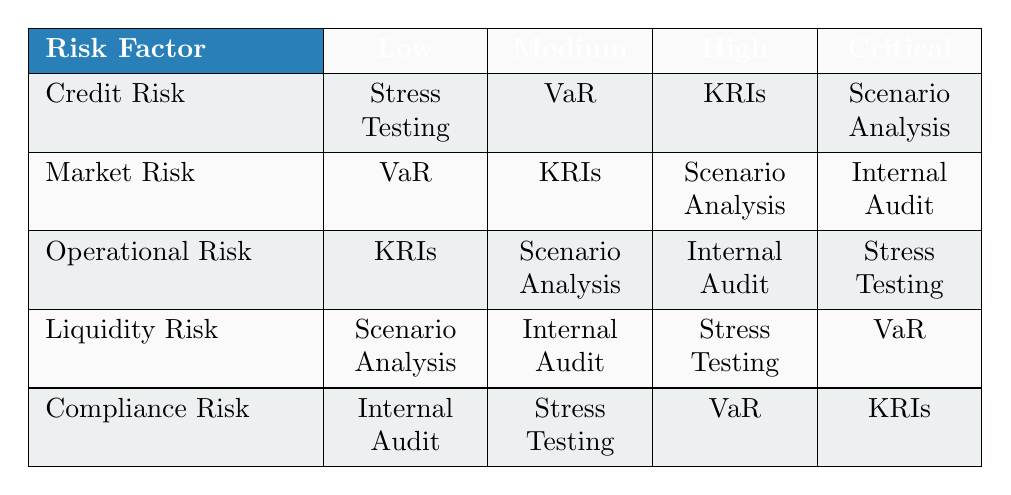What risk assessment method is used for Credit Risk at a Low level? According to the table, for Credit Risk categorized under the Low level, the method used is 'Stress Testing' as seen in the corresponding row and column intersection for Credit Risk and Low.
Answer: Stress Testing Which risk assessment method has been allocated for Operational Risk at the High level? By checking the row for Operational Risk and the column for High risk level, it is evident that the allocated method is 'Internal Audit'.
Answer: Internal Audit Is 'Stress Testing' used as a risk assessment method for Compliance Risk? Looking at the table, 'Stress Testing' appears under the row for Compliance Risk, indicating that it is indeed an assessment method for this risk factor.
Answer: Yes What are the risk assessment methods for Market Risk that fall under the Medium level? In the table, under the Market Risk row, the Medium level has 'KRIs' as the risk assessment method, combining and filtering the specific row and column yields this only method.
Answer: KRIs For which risk factor is 'Scenario Analysis' the risk assessment method at the Critical level? The table shows ‘Scenario Analysis’ under the row for Credit Risk at the Critical level, conclusively making this the appropriate risk factor and assessment method combination.
Answer: Credit Risk What is the total number of risk assessment methods listed in the table? There are 5 unique methods listed in the row under the risk assessment methods. Adding them: Stress Testing, VaR, KRIs, Scenario Analysis, and Internal Audit gives a total of 5 methods.
Answer: 5 Is it true that 'VaR' is used as a risk assessment method for both Credit Risk and Liquidity Risk? Checking the table shows that 'VaR' is used for Credit Risk at the High level but is not included for Liquidity Risk, so the statement is false.
Answer: No Which risk factor has the highest level risk assessment method of 'Stress Testing'? By examining each risk factor at the Critical level, only Operational Risk corresponds with the highest risk level having 'Stress Testing' as the assessment method, confirmed by reading the relevant row and column.
Answer: Operational Risk What risk assessment method is used for Liquidity Risk at the Low level? The table reveals that Liquidity Risk at the Low level corresponds to 'Scenario Analysis', by consulting the relevant intersection of row and column.
Answer: Scenario Analysis 